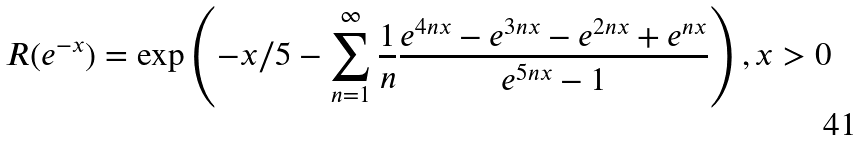<formula> <loc_0><loc_0><loc_500><loc_500>R ( e ^ { - x } ) = \exp \left ( - x / 5 - \sum ^ { \infty } _ { n = 1 } \frac { 1 } { n } \frac { e ^ { 4 n x } - e ^ { 3 n x } - e ^ { 2 n x } + e ^ { n x } } { e ^ { 5 n x } - 1 } \right ) , x > 0</formula> 